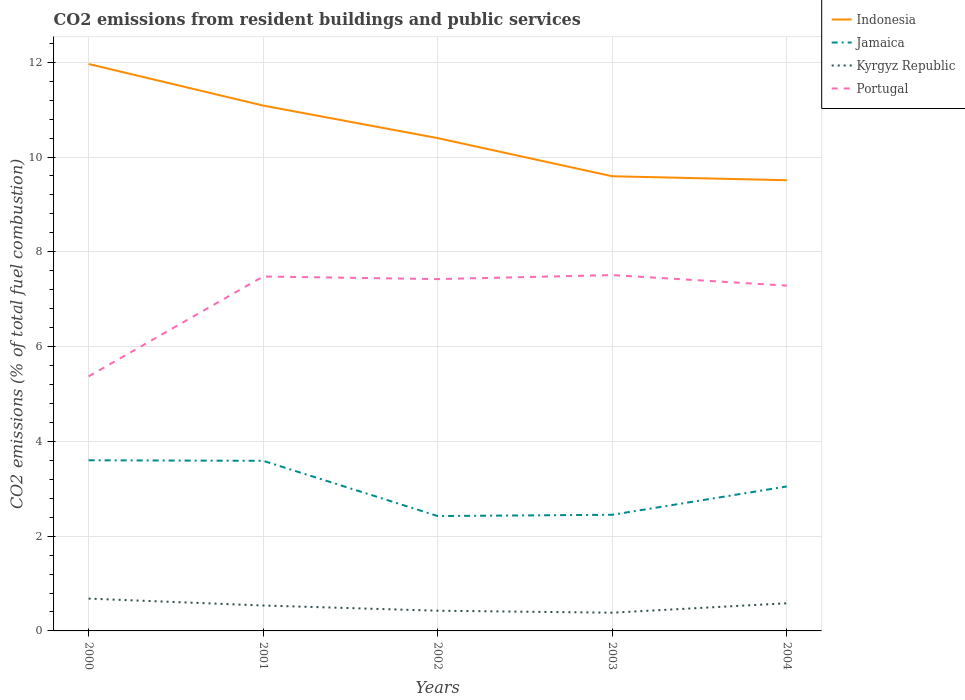How many different coloured lines are there?
Ensure brevity in your answer.  4. Is the number of lines equal to the number of legend labels?
Offer a very short reply. Yes. Across all years, what is the maximum total CO2 emitted in Portugal?
Make the answer very short. 5.37. What is the total total CO2 emitted in Kyrgyz Republic in the graph?
Ensure brevity in your answer.  0.04. What is the difference between the highest and the second highest total CO2 emitted in Portugal?
Give a very brief answer. 2.14. How many years are there in the graph?
Provide a succinct answer. 5. Does the graph contain any zero values?
Make the answer very short. No. Does the graph contain grids?
Your answer should be compact. Yes. How are the legend labels stacked?
Keep it short and to the point. Vertical. What is the title of the graph?
Make the answer very short. CO2 emissions from resident buildings and public services. What is the label or title of the X-axis?
Your response must be concise. Years. What is the label or title of the Y-axis?
Provide a succinct answer. CO2 emissions (% of total fuel combustion). What is the CO2 emissions (% of total fuel combustion) of Indonesia in 2000?
Ensure brevity in your answer.  11.96. What is the CO2 emissions (% of total fuel combustion) of Jamaica in 2000?
Provide a short and direct response. 3.6. What is the CO2 emissions (% of total fuel combustion) of Kyrgyz Republic in 2000?
Offer a terse response. 0.68. What is the CO2 emissions (% of total fuel combustion) in Portugal in 2000?
Make the answer very short. 5.37. What is the CO2 emissions (% of total fuel combustion) in Indonesia in 2001?
Provide a succinct answer. 11.09. What is the CO2 emissions (% of total fuel combustion) of Jamaica in 2001?
Your answer should be compact. 3.59. What is the CO2 emissions (% of total fuel combustion) of Kyrgyz Republic in 2001?
Give a very brief answer. 0.54. What is the CO2 emissions (% of total fuel combustion) of Portugal in 2001?
Offer a terse response. 7.48. What is the CO2 emissions (% of total fuel combustion) in Indonesia in 2002?
Provide a short and direct response. 10.4. What is the CO2 emissions (% of total fuel combustion) in Jamaica in 2002?
Offer a terse response. 2.42. What is the CO2 emissions (% of total fuel combustion) in Kyrgyz Republic in 2002?
Provide a short and direct response. 0.43. What is the CO2 emissions (% of total fuel combustion) in Portugal in 2002?
Make the answer very short. 7.42. What is the CO2 emissions (% of total fuel combustion) of Indonesia in 2003?
Provide a short and direct response. 9.59. What is the CO2 emissions (% of total fuel combustion) of Jamaica in 2003?
Offer a very short reply. 2.45. What is the CO2 emissions (% of total fuel combustion) in Kyrgyz Republic in 2003?
Provide a short and direct response. 0.38. What is the CO2 emissions (% of total fuel combustion) of Portugal in 2003?
Offer a very short reply. 7.51. What is the CO2 emissions (% of total fuel combustion) of Indonesia in 2004?
Keep it short and to the point. 9.51. What is the CO2 emissions (% of total fuel combustion) in Jamaica in 2004?
Make the answer very short. 3.05. What is the CO2 emissions (% of total fuel combustion) of Kyrgyz Republic in 2004?
Offer a terse response. 0.58. What is the CO2 emissions (% of total fuel combustion) in Portugal in 2004?
Your answer should be compact. 7.29. Across all years, what is the maximum CO2 emissions (% of total fuel combustion) in Indonesia?
Give a very brief answer. 11.96. Across all years, what is the maximum CO2 emissions (% of total fuel combustion) of Jamaica?
Provide a short and direct response. 3.6. Across all years, what is the maximum CO2 emissions (% of total fuel combustion) of Kyrgyz Republic?
Ensure brevity in your answer.  0.68. Across all years, what is the maximum CO2 emissions (% of total fuel combustion) in Portugal?
Your answer should be compact. 7.51. Across all years, what is the minimum CO2 emissions (% of total fuel combustion) in Indonesia?
Offer a very short reply. 9.51. Across all years, what is the minimum CO2 emissions (% of total fuel combustion) in Jamaica?
Provide a short and direct response. 2.42. Across all years, what is the minimum CO2 emissions (% of total fuel combustion) of Kyrgyz Republic?
Your response must be concise. 0.38. Across all years, what is the minimum CO2 emissions (% of total fuel combustion) in Portugal?
Offer a terse response. 5.37. What is the total CO2 emissions (% of total fuel combustion) of Indonesia in the graph?
Keep it short and to the point. 52.55. What is the total CO2 emissions (% of total fuel combustion) in Jamaica in the graph?
Offer a terse response. 15.11. What is the total CO2 emissions (% of total fuel combustion) of Kyrgyz Republic in the graph?
Ensure brevity in your answer.  2.61. What is the total CO2 emissions (% of total fuel combustion) of Portugal in the graph?
Your response must be concise. 35.07. What is the difference between the CO2 emissions (% of total fuel combustion) of Indonesia in 2000 and that in 2001?
Offer a very short reply. 0.88. What is the difference between the CO2 emissions (% of total fuel combustion) of Jamaica in 2000 and that in 2001?
Offer a very short reply. 0.01. What is the difference between the CO2 emissions (% of total fuel combustion) of Kyrgyz Republic in 2000 and that in 2001?
Offer a very short reply. 0.15. What is the difference between the CO2 emissions (% of total fuel combustion) in Portugal in 2000 and that in 2001?
Keep it short and to the point. -2.11. What is the difference between the CO2 emissions (% of total fuel combustion) of Indonesia in 2000 and that in 2002?
Provide a succinct answer. 1.56. What is the difference between the CO2 emissions (% of total fuel combustion) of Jamaica in 2000 and that in 2002?
Keep it short and to the point. 1.18. What is the difference between the CO2 emissions (% of total fuel combustion) of Kyrgyz Republic in 2000 and that in 2002?
Your answer should be very brief. 0.26. What is the difference between the CO2 emissions (% of total fuel combustion) of Portugal in 2000 and that in 2002?
Your response must be concise. -2.05. What is the difference between the CO2 emissions (% of total fuel combustion) of Indonesia in 2000 and that in 2003?
Your response must be concise. 2.37. What is the difference between the CO2 emissions (% of total fuel combustion) in Jamaica in 2000 and that in 2003?
Give a very brief answer. 1.15. What is the difference between the CO2 emissions (% of total fuel combustion) in Kyrgyz Republic in 2000 and that in 2003?
Offer a very short reply. 0.3. What is the difference between the CO2 emissions (% of total fuel combustion) in Portugal in 2000 and that in 2003?
Your response must be concise. -2.14. What is the difference between the CO2 emissions (% of total fuel combustion) in Indonesia in 2000 and that in 2004?
Ensure brevity in your answer.  2.45. What is the difference between the CO2 emissions (% of total fuel combustion) of Jamaica in 2000 and that in 2004?
Give a very brief answer. 0.55. What is the difference between the CO2 emissions (% of total fuel combustion) in Kyrgyz Republic in 2000 and that in 2004?
Offer a very short reply. 0.1. What is the difference between the CO2 emissions (% of total fuel combustion) of Portugal in 2000 and that in 2004?
Provide a short and direct response. -1.91. What is the difference between the CO2 emissions (% of total fuel combustion) in Indonesia in 2001 and that in 2002?
Your answer should be compact. 0.69. What is the difference between the CO2 emissions (% of total fuel combustion) of Jamaica in 2001 and that in 2002?
Provide a succinct answer. 1.17. What is the difference between the CO2 emissions (% of total fuel combustion) of Kyrgyz Republic in 2001 and that in 2002?
Your answer should be compact. 0.11. What is the difference between the CO2 emissions (% of total fuel combustion) in Portugal in 2001 and that in 2002?
Ensure brevity in your answer.  0.06. What is the difference between the CO2 emissions (% of total fuel combustion) of Indonesia in 2001 and that in 2003?
Provide a succinct answer. 1.49. What is the difference between the CO2 emissions (% of total fuel combustion) in Jamaica in 2001 and that in 2003?
Ensure brevity in your answer.  1.14. What is the difference between the CO2 emissions (% of total fuel combustion) of Kyrgyz Republic in 2001 and that in 2003?
Keep it short and to the point. 0.15. What is the difference between the CO2 emissions (% of total fuel combustion) of Portugal in 2001 and that in 2003?
Your response must be concise. -0.03. What is the difference between the CO2 emissions (% of total fuel combustion) in Indonesia in 2001 and that in 2004?
Offer a terse response. 1.58. What is the difference between the CO2 emissions (% of total fuel combustion) of Jamaica in 2001 and that in 2004?
Your response must be concise. 0.54. What is the difference between the CO2 emissions (% of total fuel combustion) in Kyrgyz Republic in 2001 and that in 2004?
Give a very brief answer. -0.05. What is the difference between the CO2 emissions (% of total fuel combustion) in Portugal in 2001 and that in 2004?
Give a very brief answer. 0.19. What is the difference between the CO2 emissions (% of total fuel combustion) in Indonesia in 2002 and that in 2003?
Ensure brevity in your answer.  0.8. What is the difference between the CO2 emissions (% of total fuel combustion) of Jamaica in 2002 and that in 2003?
Offer a terse response. -0.03. What is the difference between the CO2 emissions (% of total fuel combustion) in Kyrgyz Republic in 2002 and that in 2003?
Make the answer very short. 0.04. What is the difference between the CO2 emissions (% of total fuel combustion) of Portugal in 2002 and that in 2003?
Give a very brief answer. -0.09. What is the difference between the CO2 emissions (% of total fuel combustion) in Indonesia in 2002 and that in 2004?
Your answer should be compact. 0.89. What is the difference between the CO2 emissions (% of total fuel combustion) in Jamaica in 2002 and that in 2004?
Your answer should be very brief. -0.62. What is the difference between the CO2 emissions (% of total fuel combustion) in Kyrgyz Republic in 2002 and that in 2004?
Provide a short and direct response. -0.16. What is the difference between the CO2 emissions (% of total fuel combustion) of Portugal in 2002 and that in 2004?
Offer a terse response. 0.14. What is the difference between the CO2 emissions (% of total fuel combustion) of Indonesia in 2003 and that in 2004?
Make the answer very short. 0.08. What is the difference between the CO2 emissions (% of total fuel combustion) in Jamaica in 2003 and that in 2004?
Make the answer very short. -0.6. What is the difference between the CO2 emissions (% of total fuel combustion) of Kyrgyz Republic in 2003 and that in 2004?
Keep it short and to the point. -0.2. What is the difference between the CO2 emissions (% of total fuel combustion) in Portugal in 2003 and that in 2004?
Your answer should be very brief. 0.22. What is the difference between the CO2 emissions (% of total fuel combustion) in Indonesia in 2000 and the CO2 emissions (% of total fuel combustion) in Jamaica in 2001?
Provide a succinct answer. 8.37. What is the difference between the CO2 emissions (% of total fuel combustion) of Indonesia in 2000 and the CO2 emissions (% of total fuel combustion) of Kyrgyz Republic in 2001?
Your answer should be very brief. 11.43. What is the difference between the CO2 emissions (% of total fuel combustion) of Indonesia in 2000 and the CO2 emissions (% of total fuel combustion) of Portugal in 2001?
Your response must be concise. 4.48. What is the difference between the CO2 emissions (% of total fuel combustion) in Jamaica in 2000 and the CO2 emissions (% of total fuel combustion) in Kyrgyz Republic in 2001?
Offer a terse response. 3.06. What is the difference between the CO2 emissions (% of total fuel combustion) of Jamaica in 2000 and the CO2 emissions (% of total fuel combustion) of Portugal in 2001?
Give a very brief answer. -3.88. What is the difference between the CO2 emissions (% of total fuel combustion) in Kyrgyz Republic in 2000 and the CO2 emissions (% of total fuel combustion) in Portugal in 2001?
Make the answer very short. -6.8. What is the difference between the CO2 emissions (% of total fuel combustion) of Indonesia in 2000 and the CO2 emissions (% of total fuel combustion) of Jamaica in 2002?
Give a very brief answer. 9.54. What is the difference between the CO2 emissions (% of total fuel combustion) in Indonesia in 2000 and the CO2 emissions (% of total fuel combustion) in Kyrgyz Republic in 2002?
Make the answer very short. 11.54. What is the difference between the CO2 emissions (% of total fuel combustion) of Indonesia in 2000 and the CO2 emissions (% of total fuel combustion) of Portugal in 2002?
Your answer should be compact. 4.54. What is the difference between the CO2 emissions (% of total fuel combustion) in Jamaica in 2000 and the CO2 emissions (% of total fuel combustion) in Kyrgyz Republic in 2002?
Offer a terse response. 3.17. What is the difference between the CO2 emissions (% of total fuel combustion) of Jamaica in 2000 and the CO2 emissions (% of total fuel combustion) of Portugal in 2002?
Your answer should be compact. -3.82. What is the difference between the CO2 emissions (% of total fuel combustion) of Kyrgyz Republic in 2000 and the CO2 emissions (% of total fuel combustion) of Portugal in 2002?
Give a very brief answer. -6.74. What is the difference between the CO2 emissions (% of total fuel combustion) in Indonesia in 2000 and the CO2 emissions (% of total fuel combustion) in Jamaica in 2003?
Provide a succinct answer. 9.51. What is the difference between the CO2 emissions (% of total fuel combustion) in Indonesia in 2000 and the CO2 emissions (% of total fuel combustion) in Kyrgyz Republic in 2003?
Your answer should be compact. 11.58. What is the difference between the CO2 emissions (% of total fuel combustion) of Indonesia in 2000 and the CO2 emissions (% of total fuel combustion) of Portugal in 2003?
Provide a short and direct response. 4.45. What is the difference between the CO2 emissions (% of total fuel combustion) of Jamaica in 2000 and the CO2 emissions (% of total fuel combustion) of Kyrgyz Republic in 2003?
Keep it short and to the point. 3.22. What is the difference between the CO2 emissions (% of total fuel combustion) in Jamaica in 2000 and the CO2 emissions (% of total fuel combustion) in Portugal in 2003?
Give a very brief answer. -3.91. What is the difference between the CO2 emissions (% of total fuel combustion) in Kyrgyz Republic in 2000 and the CO2 emissions (% of total fuel combustion) in Portugal in 2003?
Your answer should be very brief. -6.83. What is the difference between the CO2 emissions (% of total fuel combustion) of Indonesia in 2000 and the CO2 emissions (% of total fuel combustion) of Jamaica in 2004?
Your response must be concise. 8.91. What is the difference between the CO2 emissions (% of total fuel combustion) in Indonesia in 2000 and the CO2 emissions (% of total fuel combustion) in Kyrgyz Republic in 2004?
Keep it short and to the point. 11.38. What is the difference between the CO2 emissions (% of total fuel combustion) of Indonesia in 2000 and the CO2 emissions (% of total fuel combustion) of Portugal in 2004?
Your answer should be very brief. 4.68. What is the difference between the CO2 emissions (% of total fuel combustion) of Jamaica in 2000 and the CO2 emissions (% of total fuel combustion) of Kyrgyz Republic in 2004?
Offer a very short reply. 3.02. What is the difference between the CO2 emissions (% of total fuel combustion) in Jamaica in 2000 and the CO2 emissions (% of total fuel combustion) in Portugal in 2004?
Give a very brief answer. -3.69. What is the difference between the CO2 emissions (% of total fuel combustion) in Kyrgyz Republic in 2000 and the CO2 emissions (% of total fuel combustion) in Portugal in 2004?
Give a very brief answer. -6.6. What is the difference between the CO2 emissions (% of total fuel combustion) of Indonesia in 2001 and the CO2 emissions (% of total fuel combustion) of Jamaica in 2002?
Offer a terse response. 8.66. What is the difference between the CO2 emissions (% of total fuel combustion) in Indonesia in 2001 and the CO2 emissions (% of total fuel combustion) in Kyrgyz Republic in 2002?
Your answer should be compact. 10.66. What is the difference between the CO2 emissions (% of total fuel combustion) of Indonesia in 2001 and the CO2 emissions (% of total fuel combustion) of Portugal in 2002?
Your response must be concise. 3.66. What is the difference between the CO2 emissions (% of total fuel combustion) in Jamaica in 2001 and the CO2 emissions (% of total fuel combustion) in Kyrgyz Republic in 2002?
Offer a terse response. 3.16. What is the difference between the CO2 emissions (% of total fuel combustion) in Jamaica in 2001 and the CO2 emissions (% of total fuel combustion) in Portugal in 2002?
Make the answer very short. -3.83. What is the difference between the CO2 emissions (% of total fuel combustion) in Kyrgyz Republic in 2001 and the CO2 emissions (% of total fuel combustion) in Portugal in 2002?
Offer a terse response. -6.89. What is the difference between the CO2 emissions (% of total fuel combustion) of Indonesia in 2001 and the CO2 emissions (% of total fuel combustion) of Jamaica in 2003?
Make the answer very short. 8.63. What is the difference between the CO2 emissions (% of total fuel combustion) in Indonesia in 2001 and the CO2 emissions (% of total fuel combustion) in Kyrgyz Republic in 2003?
Give a very brief answer. 10.7. What is the difference between the CO2 emissions (% of total fuel combustion) of Indonesia in 2001 and the CO2 emissions (% of total fuel combustion) of Portugal in 2003?
Provide a succinct answer. 3.58. What is the difference between the CO2 emissions (% of total fuel combustion) in Jamaica in 2001 and the CO2 emissions (% of total fuel combustion) in Kyrgyz Republic in 2003?
Your response must be concise. 3.21. What is the difference between the CO2 emissions (% of total fuel combustion) in Jamaica in 2001 and the CO2 emissions (% of total fuel combustion) in Portugal in 2003?
Your response must be concise. -3.92. What is the difference between the CO2 emissions (% of total fuel combustion) in Kyrgyz Republic in 2001 and the CO2 emissions (% of total fuel combustion) in Portugal in 2003?
Your response must be concise. -6.97. What is the difference between the CO2 emissions (% of total fuel combustion) of Indonesia in 2001 and the CO2 emissions (% of total fuel combustion) of Jamaica in 2004?
Provide a short and direct response. 8.04. What is the difference between the CO2 emissions (% of total fuel combustion) of Indonesia in 2001 and the CO2 emissions (% of total fuel combustion) of Kyrgyz Republic in 2004?
Provide a short and direct response. 10.5. What is the difference between the CO2 emissions (% of total fuel combustion) in Indonesia in 2001 and the CO2 emissions (% of total fuel combustion) in Portugal in 2004?
Provide a short and direct response. 3.8. What is the difference between the CO2 emissions (% of total fuel combustion) in Jamaica in 2001 and the CO2 emissions (% of total fuel combustion) in Kyrgyz Republic in 2004?
Make the answer very short. 3.01. What is the difference between the CO2 emissions (% of total fuel combustion) in Jamaica in 2001 and the CO2 emissions (% of total fuel combustion) in Portugal in 2004?
Keep it short and to the point. -3.7. What is the difference between the CO2 emissions (% of total fuel combustion) in Kyrgyz Republic in 2001 and the CO2 emissions (% of total fuel combustion) in Portugal in 2004?
Offer a very short reply. -6.75. What is the difference between the CO2 emissions (% of total fuel combustion) in Indonesia in 2002 and the CO2 emissions (% of total fuel combustion) in Jamaica in 2003?
Make the answer very short. 7.95. What is the difference between the CO2 emissions (% of total fuel combustion) of Indonesia in 2002 and the CO2 emissions (% of total fuel combustion) of Kyrgyz Republic in 2003?
Provide a short and direct response. 10.01. What is the difference between the CO2 emissions (% of total fuel combustion) in Indonesia in 2002 and the CO2 emissions (% of total fuel combustion) in Portugal in 2003?
Offer a very short reply. 2.89. What is the difference between the CO2 emissions (% of total fuel combustion) of Jamaica in 2002 and the CO2 emissions (% of total fuel combustion) of Kyrgyz Republic in 2003?
Provide a succinct answer. 2.04. What is the difference between the CO2 emissions (% of total fuel combustion) in Jamaica in 2002 and the CO2 emissions (% of total fuel combustion) in Portugal in 2003?
Offer a very short reply. -5.08. What is the difference between the CO2 emissions (% of total fuel combustion) of Kyrgyz Republic in 2002 and the CO2 emissions (% of total fuel combustion) of Portugal in 2003?
Ensure brevity in your answer.  -7.08. What is the difference between the CO2 emissions (% of total fuel combustion) of Indonesia in 2002 and the CO2 emissions (% of total fuel combustion) of Jamaica in 2004?
Your answer should be compact. 7.35. What is the difference between the CO2 emissions (% of total fuel combustion) in Indonesia in 2002 and the CO2 emissions (% of total fuel combustion) in Kyrgyz Republic in 2004?
Your answer should be compact. 9.82. What is the difference between the CO2 emissions (% of total fuel combustion) in Indonesia in 2002 and the CO2 emissions (% of total fuel combustion) in Portugal in 2004?
Your response must be concise. 3.11. What is the difference between the CO2 emissions (% of total fuel combustion) of Jamaica in 2002 and the CO2 emissions (% of total fuel combustion) of Kyrgyz Republic in 2004?
Your response must be concise. 1.84. What is the difference between the CO2 emissions (% of total fuel combustion) in Jamaica in 2002 and the CO2 emissions (% of total fuel combustion) in Portugal in 2004?
Offer a terse response. -4.86. What is the difference between the CO2 emissions (% of total fuel combustion) in Kyrgyz Republic in 2002 and the CO2 emissions (% of total fuel combustion) in Portugal in 2004?
Give a very brief answer. -6.86. What is the difference between the CO2 emissions (% of total fuel combustion) in Indonesia in 2003 and the CO2 emissions (% of total fuel combustion) in Jamaica in 2004?
Offer a very short reply. 6.55. What is the difference between the CO2 emissions (% of total fuel combustion) in Indonesia in 2003 and the CO2 emissions (% of total fuel combustion) in Kyrgyz Republic in 2004?
Provide a short and direct response. 9.01. What is the difference between the CO2 emissions (% of total fuel combustion) in Indonesia in 2003 and the CO2 emissions (% of total fuel combustion) in Portugal in 2004?
Offer a very short reply. 2.31. What is the difference between the CO2 emissions (% of total fuel combustion) in Jamaica in 2003 and the CO2 emissions (% of total fuel combustion) in Kyrgyz Republic in 2004?
Offer a very short reply. 1.87. What is the difference between the CO2 emissions (% of total fuel combustion) in Jamaica in 2003 and the CO2 emissions (% of total fuel combustion) in Portugal in 2004?
Your answer should be compact. -4.84. What is the difference between the CO2 emissions (% of total fuel combustion) in Kyrgyz Republic in 2003 and the CO2 emissions (% of total fuel combustion) in Portugal in 2004?
Make the answer very short. -6.9. What is the average CO2 emissions (% of total fuel combustion) of Indonesia per year?
Offer a terse response. 10.51. What is the average CO2 emissions (% of total fuel combustion) of Jamaica per year?
Offer a terse response. 3.02. What is the average CO2 emissions (% of total fuel combustion) in Kyrgyz Republic per year?
Give a very brief answer. 0.52. What is the average CO2 emissions (% of total fuel combustion) of Portugal per year?
Keep it short and to the point. 7.01. In the year 2000, what is the difference between the CO2 emissions (% of total fuel combustion) in Indonesia and CO2 emissions (% of total fuel combustion) in Jamaica?
Keep it short and to the point. 8.36. In the year 2000, what is the difference between the CO2 emissions (% of total fuel combustion) of Indonesia and CO2 emissions (% of total fuel combustion) of Kyrgyz Republic?
Give a very brief answer. 11.28. In the year 2000, what is the difference between the CO2 emissions (% of total fuel combustion) in Indonesia and CO2 emissions (% of total fuel combustion) in Portugal?
Provide a succinct answer. 6.59. In the year 2000, what is the difference between the CO2 emissions (% of total fuel combustion) of Jamaica and CO2 emissions (% of total fuel combustion) of Kyrgyz Republic?
Give a very brief answer. 2.92. In the year 2000, what is the difference between the CO2 emissions (% of total fuel combustion) in Jamaica and CO2 emissions (% of total fuel combustion) in Portugal?
Your response must be concise. -1.77. In the year 2000, what is the difference between the CO2 emissions (% of total fuel combustion) of Kyrgyz Republic and CO2 emissions (% of total fuel combustion) of Portugal?
Your response must be concise. -4.69. In the year 2001, what is the difference between the CO2 emissions (% of total fuel combustion) of Indonesia and CO2 emissions (% of total fuel combustion) of Jamaica?
Your response must be concise. 7.5. In the year 2001, what is the difference between the CO2 emissions (% of total fuel combustion) in Indonesia and CO2 emissions (% of total fuel combustion) in Kyrgyz Republic?
Offer a terse response. 10.55. In the year 2001, what is the difference between the CO2 emissions (% of total fuel combustion) in Indonesia and CO2 emissions (% of total fuel combustion) in Portugal?
Give a very brief answer. 3.61. In the year 2001, what is the difference between the CO2 emissions (% of total fuel combustion) in Jamaica and CO2 emissions (% of total fuel combustion) in Kyrgyz Republic?
Offer a terse response. 3.05. In the year 2001, what is the difference between the CO2 emissions (% of total fuel combustion) of Jamaica and CO2 emissions (% of total fuel combustion) of Portugal?
Provide a short and direct response. -3.89. In the year 2001, what is the difference between the CO2 emissions (% of total fuel combustion) in Kyrgyz Republic and CO2 emissions (% of total fuel combustion) in Portugal?
Make the answer very short. -6.94. In the year 2002, what is the difference between the CO2 emissions (% of total fuel combustion) in Indonesia and CO2 emissions (% of total fuel combustion) in Jamaica?
Your answer should be very brief. 7.97. In the year 2002, what is the difference between the CO2 emissions (% of total fuel combustion) in Indonesia and CO2 emissions (% of total fuel combustion) in Kyrgyz Republic?
Offer a terse response. 9.97. In the year 2002, what is the difference between the CO2 emissions (% of total fuel combustion) in Indonesia and CO2 emissions (% of total fuel combustion) in Portugal?
Provide a short and direct response. 2.98. In the year 2002, what is the difference between the CO2 emissions (% of total fuel combustion) in Jamaica and CO2 emissions (% of total fuel combustion) in Kyrgyz Republic?
Ensure brevity in your answer.  2. In the year 2002, what is the difference between the CO2 emissions (% of total fuel combustion) of Jamaica and CO2 emissions (% of total fuel combustion) of Portugal?
Your response must be concise. -5. In the year 2002, what is the difference between the CO2 emissions (% of total fuel combustion) of Kyrgyz Republic and CO2 emissions (% of total fuel combustion) of Portugal?
Provide a short and direct response. -7. In the year 2003, what is the difference between the CO2 emissions (% of total fuel combustion) of Indonesia and CO2 emissions (% of total fuel combustion) of Jamaica?
Offer a very short reply. 7.14. In the year 2003, what is the difference between the CO2 emissions (% of total fuel combustion) of Indonesia and CO2 emissions (% of total fuel combustion) of Kyrgyz Republic?
Keep it short and to the point. 9.21. In the year 2003, what is the difference between the CO2 emissions (% of total fuel combustion) in Indonesia and CO2 emissions (% of total fuel combustion) in Portugal?
Offer a very short reply. 2.09. In the year 2003, what is the difference between the CO2 emissions (% of total fuel combustion) in Jamaica and CO2 emissions (% of total fuel combustion) in Kyrgyz Republic?
Offer a terse response. 2.07. In the year 2003, what is the difference between the CO2 emissions (% of total fuel combustion) of Jamaica and CO2 emissions (% of total fuel combustion) of Portugal?
Your response must be concise. -5.06. In the year 2003, what is the difference between the CO2 emissions (% of total fuel combustion) in Kyrgyz Republic and CO2 emissions (% of total fuel combustion) in Portugal?
Your answer should be compact. -7.12. In the year 2004, what is the difference between the CO2 emissions (% of total fuel combustion) of Indonesia and CO2 emissions (% of total fuel combustion) of Jamaica?
Your answer should be compact. 6.46. In the year 2004, what is the difference between the CO2 emissions (% of total fuel combustion) in Indonesia and CO2 emissions (% of total fuel combustion) in Kyrgyz Republic?
Make the answer very short. 8.93. In the year 2004, what is the difference between the CO2 emissions (% of total fuel combustion) in Indonesia and CO2 emissions (% of total fuel combustion) in Portugal?
Offer a very short reply. 2.22. In the year 2004, what is the difference between the CO2 emissions (% of total fuel combustion) of Jamaica and CO2 emissions (% of total fuel combustion) of Kyrgyz Republic?
Offer a very short reply. 2.46. In the year 2004, what is the difference between the CO2 emissions (% of total fuel combustion) of Jamaica and CO2 emissions (% of total fuel combustion) of Portugal?
Keep it short and to the point. -4.24. In the year 2004, what is the difference between the CO2 emissions (% of total fuel combustion) in Kyrgyz Republic and CO2 emissions (% of total fuel combustion) in Portugal?
Offer a terse response. -6.7. What is the ratio of the CO2 emissions (% of total fuel combustion) in Indonesia in 2000 to that in 2001?
Ensure brevity in your answer.  1.08. What is the ratio of the CO2 emissions (% of total fuel combustion) in Jamaica in 2000 to that in 2001?
Your response must be concise. 1. What is the ratio of the CO2 emissions (% of total fuel combustion) of Kyrgyz Republic in 2000 to that in 2001?
Ensure brevity in your answer.  1.27. What is the ratio of the CO2 emissions (% of total fuel combustion) of Portugal in 2000 to that in 2001?
Ensure brevity in your answer.  0.72. What is the ratio of the CO2 emissions (% of total fuel combustion) of Indonesia in 2000 to that in 2002?
Provide a succinct answer. 1.15. What is the ratio of the CO2 emissions (% of total fuel combustion) of Jamaica in 2000 to that in 2002?
Offer a very short reply. 1.49. What is the ratio of the CO2 emissions (% of total fuel combustion) in Kyrgyz Republic in 2000 to that in 2002?
Provide a short and direct response. 1.6. What is the ratio of the CO2 emissions (% of total fuel combustion) in Portugal in 2000 to that in 2002?
Offer a terse response. 0.72. What is the ratio of the CO2 emissions (% of total fuel combustion) of Indonesia in 2000 to that in 2003?
Offer a terse response. 1.25. What is the ratio of the CO2 emissions (% of total fuel combustion) of Jamaica in 2000 to that in 2003?
Make the answer very short. 1.47. What is the ratio of the CO2 emissions (% of total fuel combustion) of Kyrgyz Republic in 2000 to that in 2003?
Provide a succinct answer. 1.77. What is the ratio of the CO2 emissions (% of total fuel combustion) of Portugal in 2000 to that in 2003?
Your answer should be very brief. 0.72. What is the ratio of the CO2 emissions (% of total fuel combustion) in Indonesia in 2000 to that in 2004?
Ensure brevity in your answer.  1.26. What is the ratio of the CO2 emissions (% of total fuel combustion) of Jamaica in 2000 to that in 2004?
Offer a terse response. 1.18. What is the ratio of the CO2 emissions (% of total fuel combustion) of Kyrgyz Republic in 2000 to that in 2004?
Provide a short and direct response. 1.17. What is the ratio of the CO2 emissions (% of total fuel combustion) of Portugal in 2000 to that in 2004?
Your response must be concise. 0.74. What is the ratio of the CO2 emissions (% of total fuel combustion) of Indonesia in 2001 to that in 2002?
Ensure brevity in your answer.  1.07. What is the ratio of the CO2 emissions (% of total fuel combustion) of Jamaica in 2001 to that in 2002?
Make the answer very short. 1.48. What is the ratio of the CO2 emissions (% of total fuel combustion) of Kyrgyz Republic in 2001 to that in 2002?
Your response must be concise. 1.26. What is the ratio of the CO2 emissions (% of total fuel combustion) of Portugal in 2001 to that in 2002?
Your response must be concise. 1.01. What is the ratio of the CO2 emissions (% of total fuel combustion) in Indonesia in 2001 to that in 2003?
Provide a succinct answer. 1.16. What is the ratio of the CO2 emissions (% of total fuel combustion) in Jamaica in 2001 to that in 2003?
Give a very brief answer. 1.46. What is the ratio of the CO2 emissions (% of total fuel combustion) of Kyrgyz Republic in 2001 to that in 2003?
Ensure brevity in your answer.  1.39. What is the ratio of the CO2 emissions (% of total fuel combustion) of Portugal in 2001 to that in 2003?
Your response must be concise. 1. What is the ratio of the CO2 emissions (% of total fuel combustion) of Indonesia in 2001 to that in 2004?
Provide a succinct answer. 1.17. What is the ratio of the CO2 emissions (% of total fuel combustion) of Jamaica in 2001 to that in 2004?
Keep it short and to the point. 1.18. What is the ratio of the CO2 emissions (% of total fuel combustion) in Kyrgyz Republic in 2001 to that in 2004?
Offer a very short reply. 0.92. What is the ratio of the CO2 emissions (% of total fuel combustion) of Portugal in 2001 to that in 2004?
Keep it short and to the point. 1.03. What is the ratio of the CO2 emissions (% of total fuel combustion) in Indonesia in 2002 to that in 2003?
Offer a terse response. 1.08. What is the ratio of the CO2 emissions (% of total fuel combustion) of Jamaica in 2002 to that in 2003?
Keep it short and to the point. 0.99. What is the ratio of the CO2 emissions (% of total fuel combustion) of Kyrgyz Republic in 2002 to that in 2003?
Ensure brevity in your answer.  1.11. What is the ratio of the CO2 emissions (% of total fuel combustion) in Portugal in 2002 to that in 2003?
Provide a succinct answer. 0.99. What is the ratio of the CO2 emissions (% of total fuel combustion) in Indonesia in 2002 to that in 2004?
Your answer should be compact. 1.09. What is the ratio of the CO2 emissions (% of total fuel combustion) in Jamaica in 2002 to that in 2004?
Give a very brief answer. 0.8. What is the ratio of the CO2 emissions (% of total fuel combustion) in Kyrgyz Republic in 2002 to that in 2004?
Offer a terse response. 0.73. What is the ratio of the CO2 emissions (% of total fuel combustion) in Portugal in 2002 to that in 2004?
Provide a succinct answer. 1.02. What is the ratio of the CO2 emissions (% of total fuel combustion) of Indonesia in 2003 to that in 2004?
Your answer should be very brief. 1.01. What is the ratio of the CO2 emissions (% of total fuel combustion) in Jamaica in 2003 to that in 2004?
Ensure brevity in your answer.  0.8. What is the ratio of the CO2 emissions (% of total fuel combustion) of Kyrgyz Republic in 2003 to that in 2004?
Your answer should be compact. 0.66. What is the ratio of the CO2 emissions (% of total fuel combustion) of Portugal in 2003 to that in 2004?
Provide a succinct answer. 1.03. What is the difference between the highest and the second highest CO2 emissions (% of total fuel combustion) of Indonesia?
Your answer should be compact. 0.88. What is the difference between the highest and the second highest CO2 emissions (% of total fuel combustion) of Jamaica?
Provide a succinct answer. 0.01. What is the difference between the highest and the second highest CO2 emissions (% of total fuel combustion) in Kyrgyz Republic?
Your answer should be compact. 0.1. What is the difference between the highest and the second highest CO2 emissions (% of total fuel combustion) of Portugal?
Make the answer very short. 0.03. What is the difference between the highest and the lowest CO2 emissions (% of total fuel combustion) of Indonesia?
Make the answer very short. 2.45. What is the difference between the highest and the lowest CO2 emissions (% of total fuel combustion) in Jamaica?
Your answer should be very brief. 1.18. What is the difference between the highest and the lowest CO2 emissions (% of total fuel combustion) in Kyrgyz Republic?
Ensure brevity in your answer.  0.3. What is the difference between the highest and the lowest CO2 emissions (% of total fuel combustion) in Portugal?
Your answer should be compact. 2.14. 